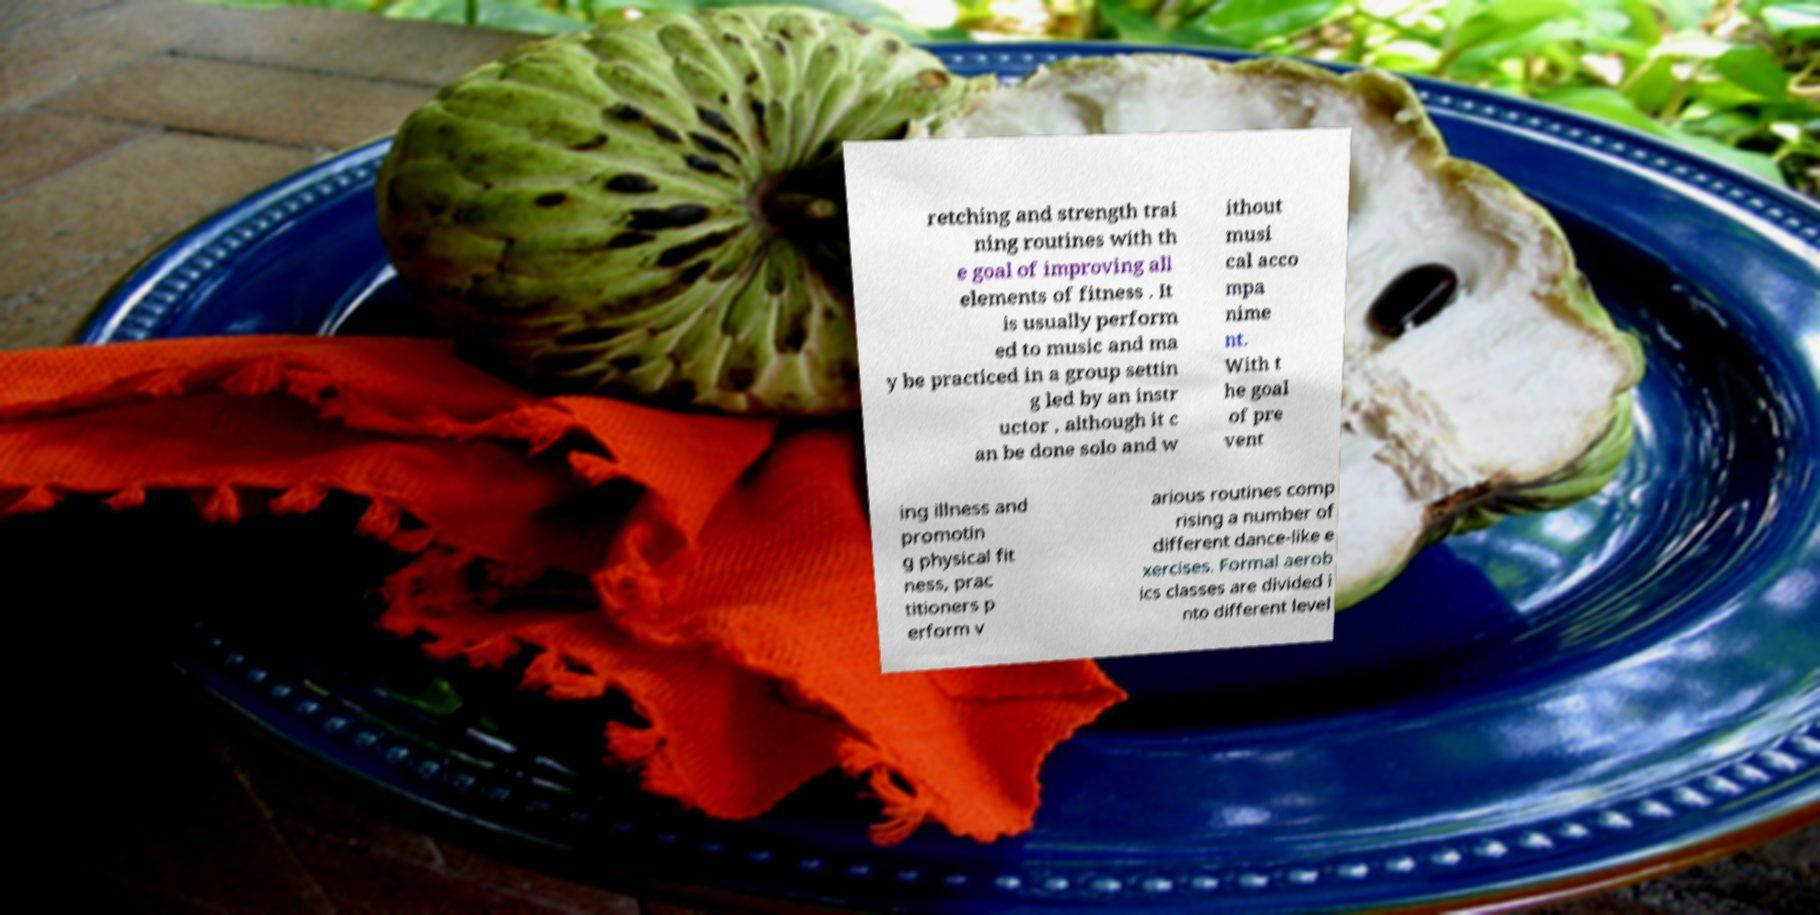For documentation purposes, I need the text within this image transcribed. Could you provide that? retching and strength trai ning routines with th e goal of improving all elements of fitness . It is usually perform ed to music and ma y be practiced in a group settin g led by an instr uctor , although it c an be done solo and w ithout musi cal acco mpa nime nt. With t he goal of pre vent ing illness and promotin g physical fit ness, prac titioners p erform v arious routines comp rising a number of different dance-like e xercises. Formal aerob ics classes are divided i nto different level 